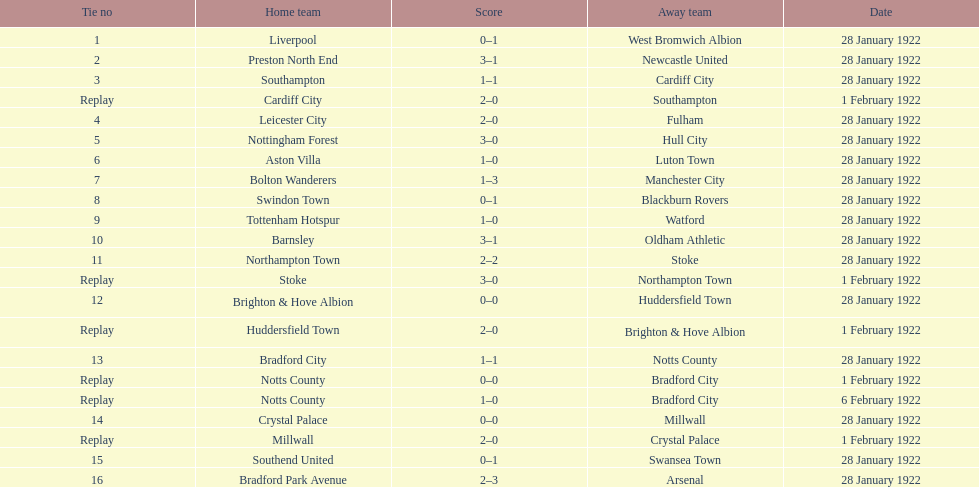When did they have a play before february 1? 28 January 1922. 